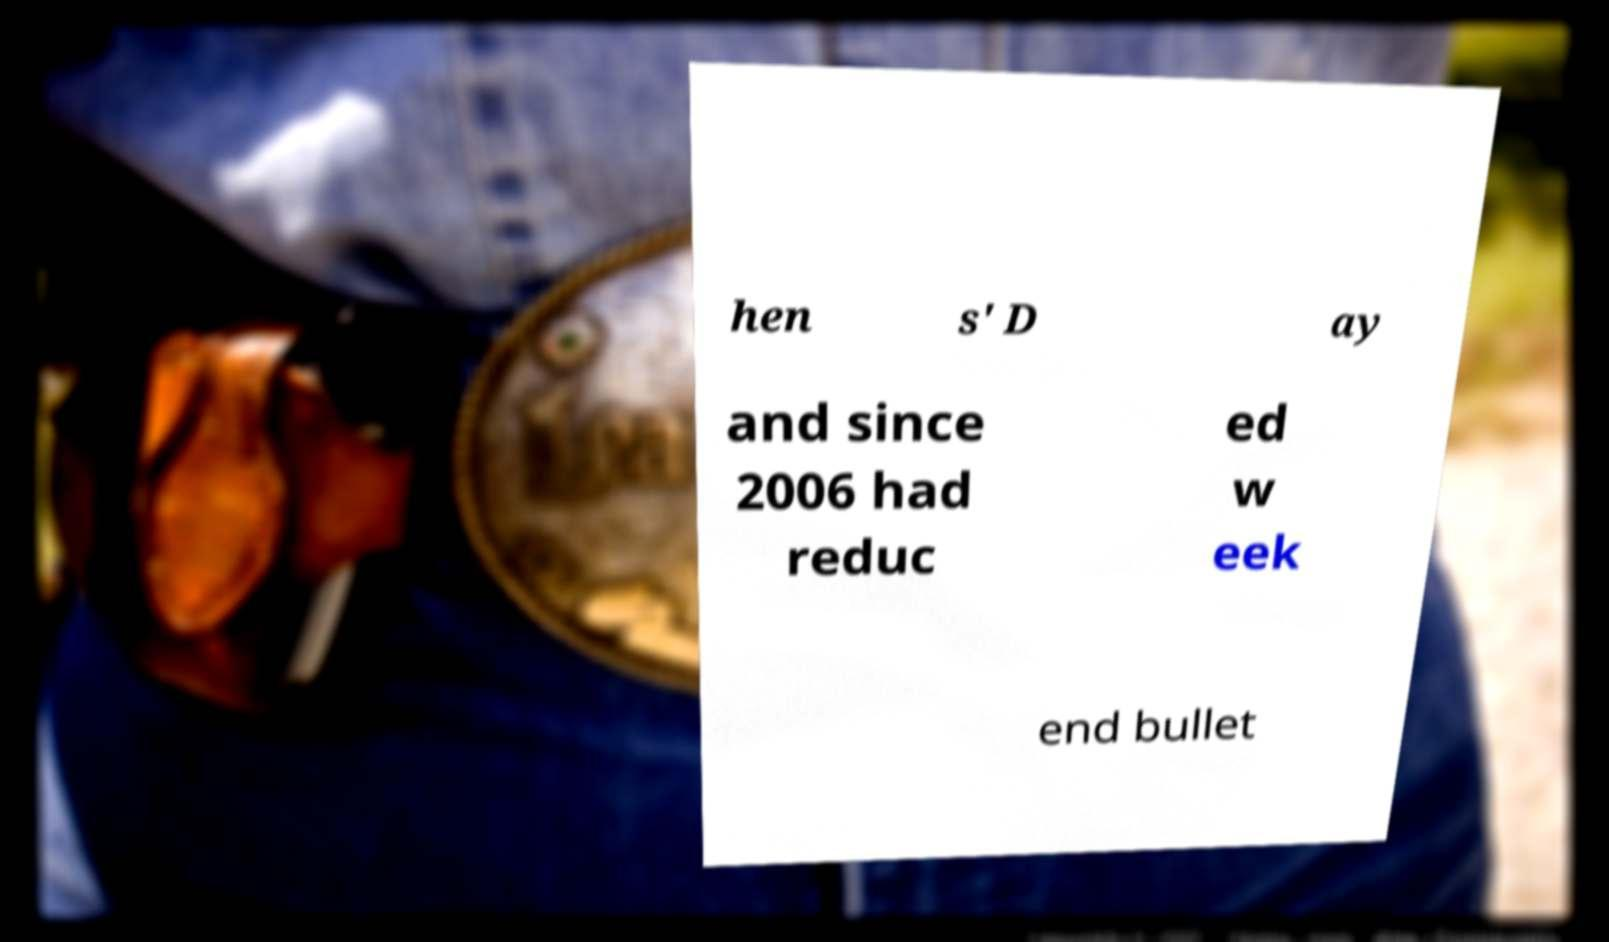I need the written content from this picture converted into text. Can you do that? hen s' D ay and since 2006 had reduc ed w eek end bullet 